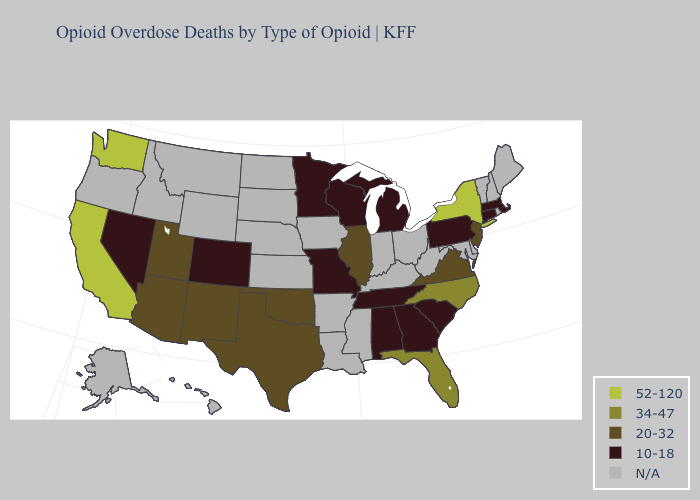Name the states that have a value in the range 20-32?
Concise answer only. Arizona, Illinois, New Jersey, New Mexico, Oklahoma, Texas, Utah, Virginia. What is the highest value in the West ?
Concise answer only. 52-120. What is the lowest value in states that border Tennessee?
Short answer required. 10-18. What is the value of Oregon?
Quick response, please. N/A. What is the value of Louisiana?
Answer briefly. N/A. What is the value of Ohio?
Short answer required. N/A. What is the value of Pennsylvania?
Short answer required. 10-18. Does the map have missing data?
Short answer required. Yes. Name the states that have a value in the range N/A?
Quick response, please. Alaska, Arkansas, Delaware, Hawaii, Idaho, Indiana, Iowa, Kansas, Kentucky, Louisiana, Maine, Maryland, Mississippi, Montana, Nebraska, New Hampshire, North Dakota, Ohio, Oregon, Rhode Island, South Dakota, Vermont, West Virginia, Wyoming. Is the legend a continuous bar?
Answer briefly. No. What is the lowest value in the West?
Be succinct. 10-18. Which states hav the highest value in the South?
Quick response, please. Florida, North Carolina. What is the value of Hawaii?
Give a very brief answer. N/A. 